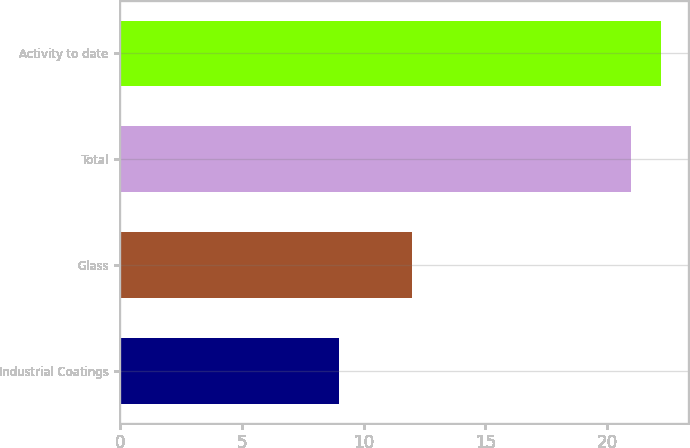<chart> <loc_0><loc_0><loc_500><loc_500><bar_chart><fcel>Industrial Coatings<fcel>Glass<fcel>Total<fcel>Activity to date<nl><fcel>9<fcel>12<fcel>21<fcel>22.2<nl></chart> 